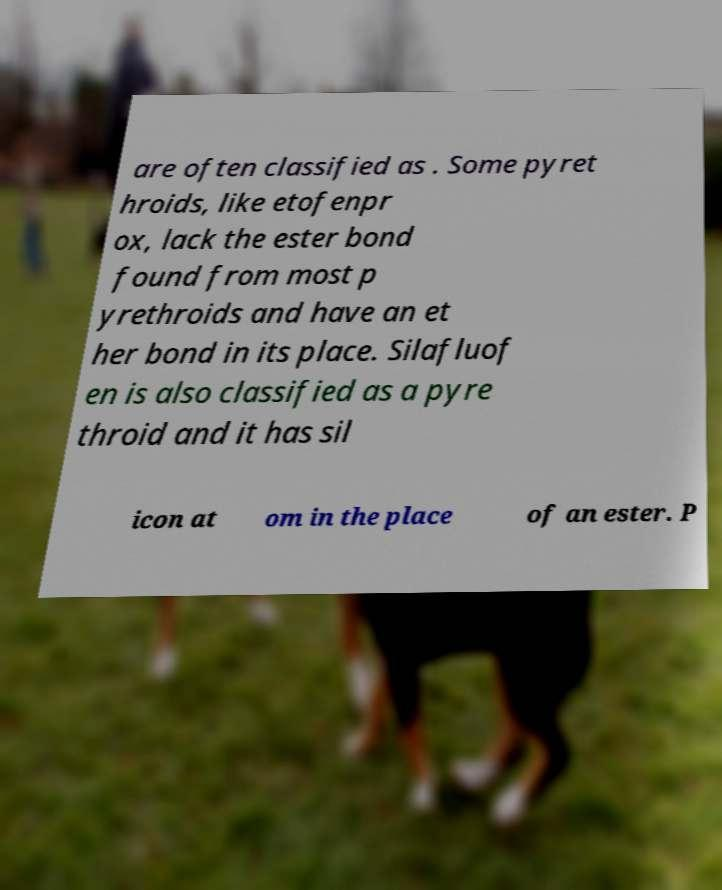Could you assist in decoding the text presented in this image and type it out clearly? are often classified as . Some pyret hroids, like etofenpr ox, lack the ester bond found from most p yrethroids and have an et her bond in its place. Silafluof en is also classified as a pyre throid and it has sil icon at om in the place of an ester. P 